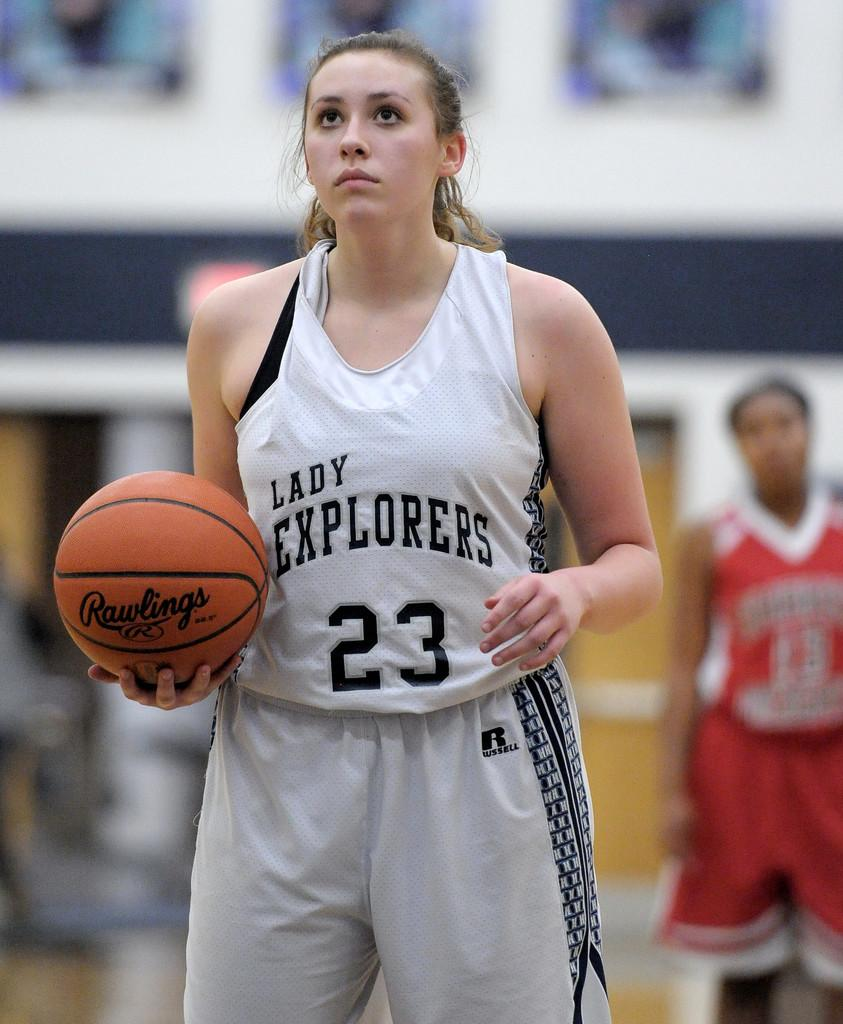<image>
Summarize the visual content of the image. A basketball player has the team name Lady Explorers on her jersey. 